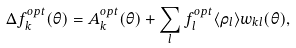Convert formula to latex. <formula><loc_0><loc_0><loc_500><loc_500>\Delta f _ { k } ^ { o p t } ( \theta ) = A _ { k } ^ { o p t } ( \theta ) + \sum _ { l } f _ { l } ^ { o p t } \langle \rho _ { l } \rangle w _ { k l } ( \theta ) ,</formula> 